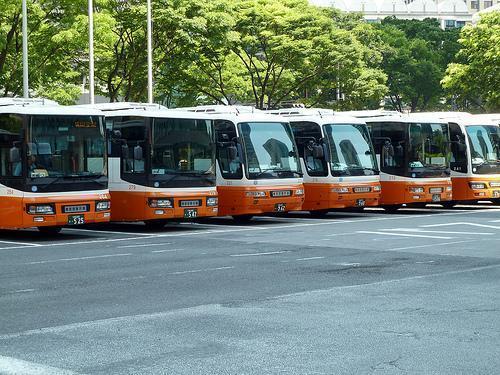How many buses are there?
Give a very brief answer. 6. 